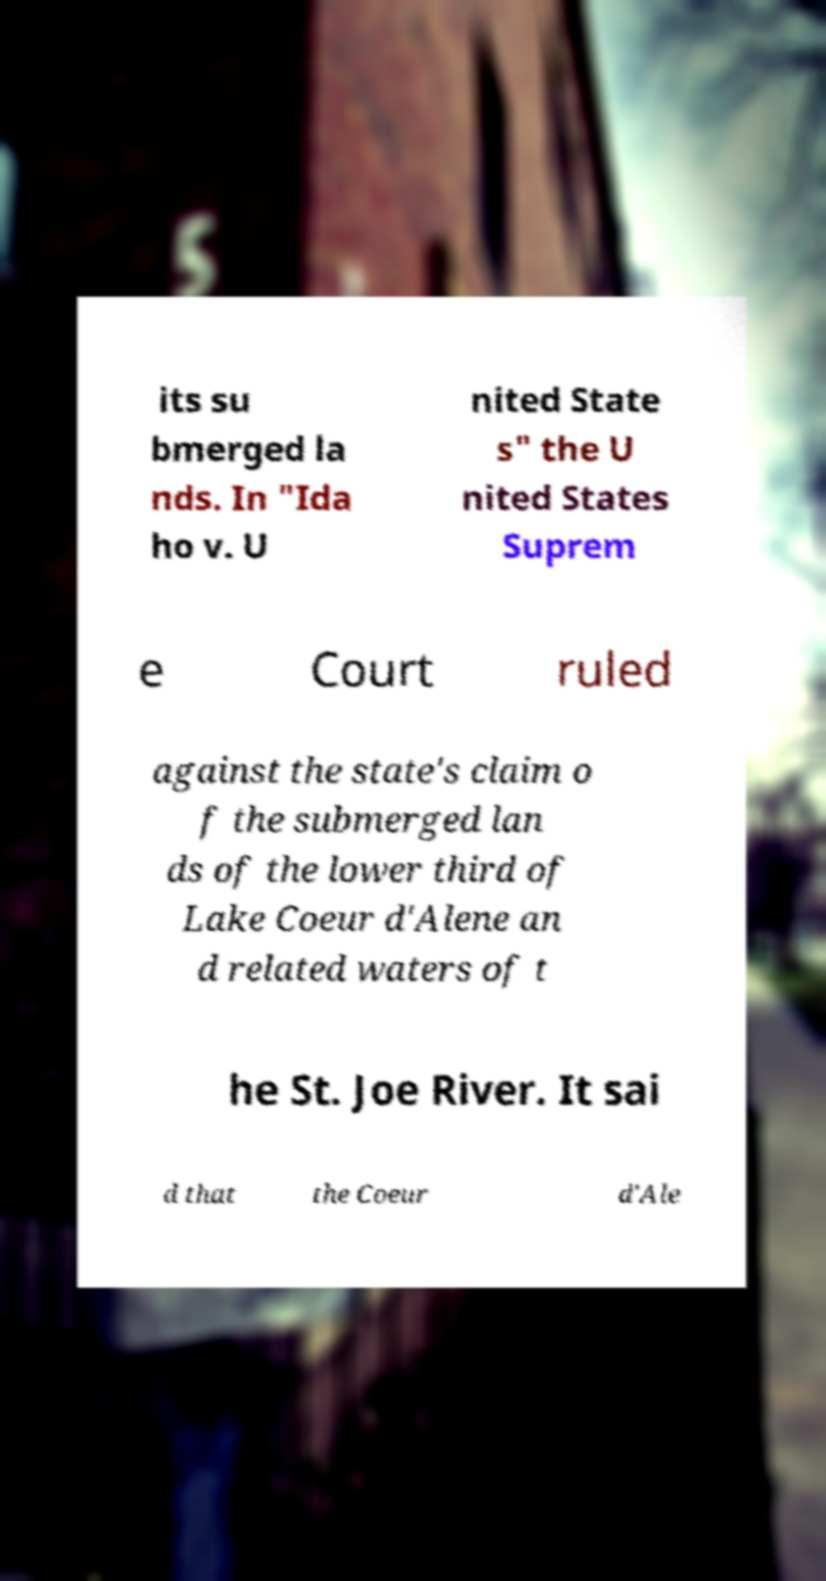Please identify and transcribe the text found in this image. its su bmerged la nds. In "Ida ho v. U nited State s" the U nited States Suprem e Court ruled against the state's claim o f the submerged lan ds of the lower third of Lake Coeur d'Alene an d related waters of t he St. Joe River. It sai d that the Coeur d'Ale 